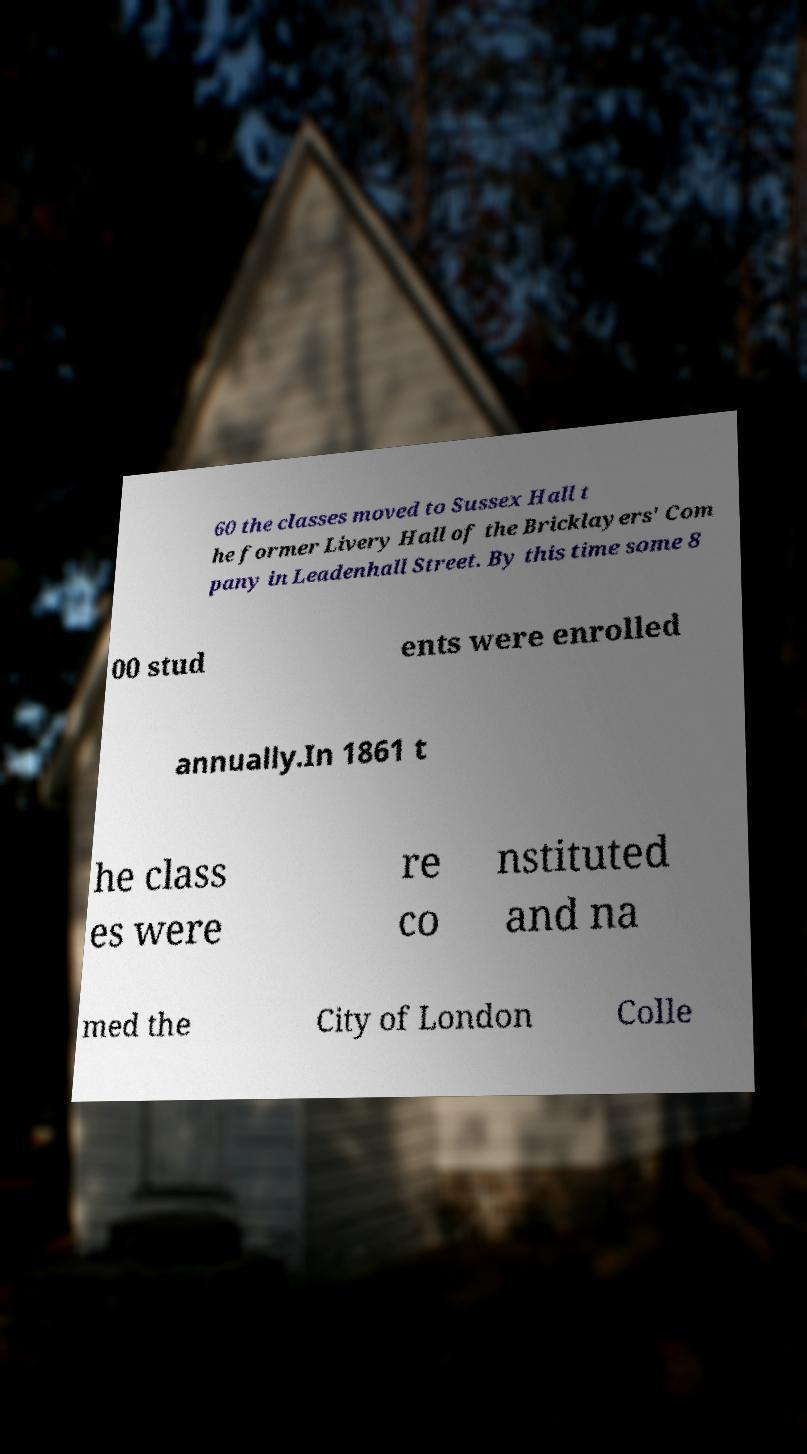Can you accurately transcribe the text from the provided image for me? 60 the classes moved to Sussex Hall t he former Livery Hall of the Bricklayers' Com pany in Leadenhall Street. By this time some 8 00 stud ents were enrolled annually.In 1861 t he class es were re co nstituted and na med the City of London Colle 